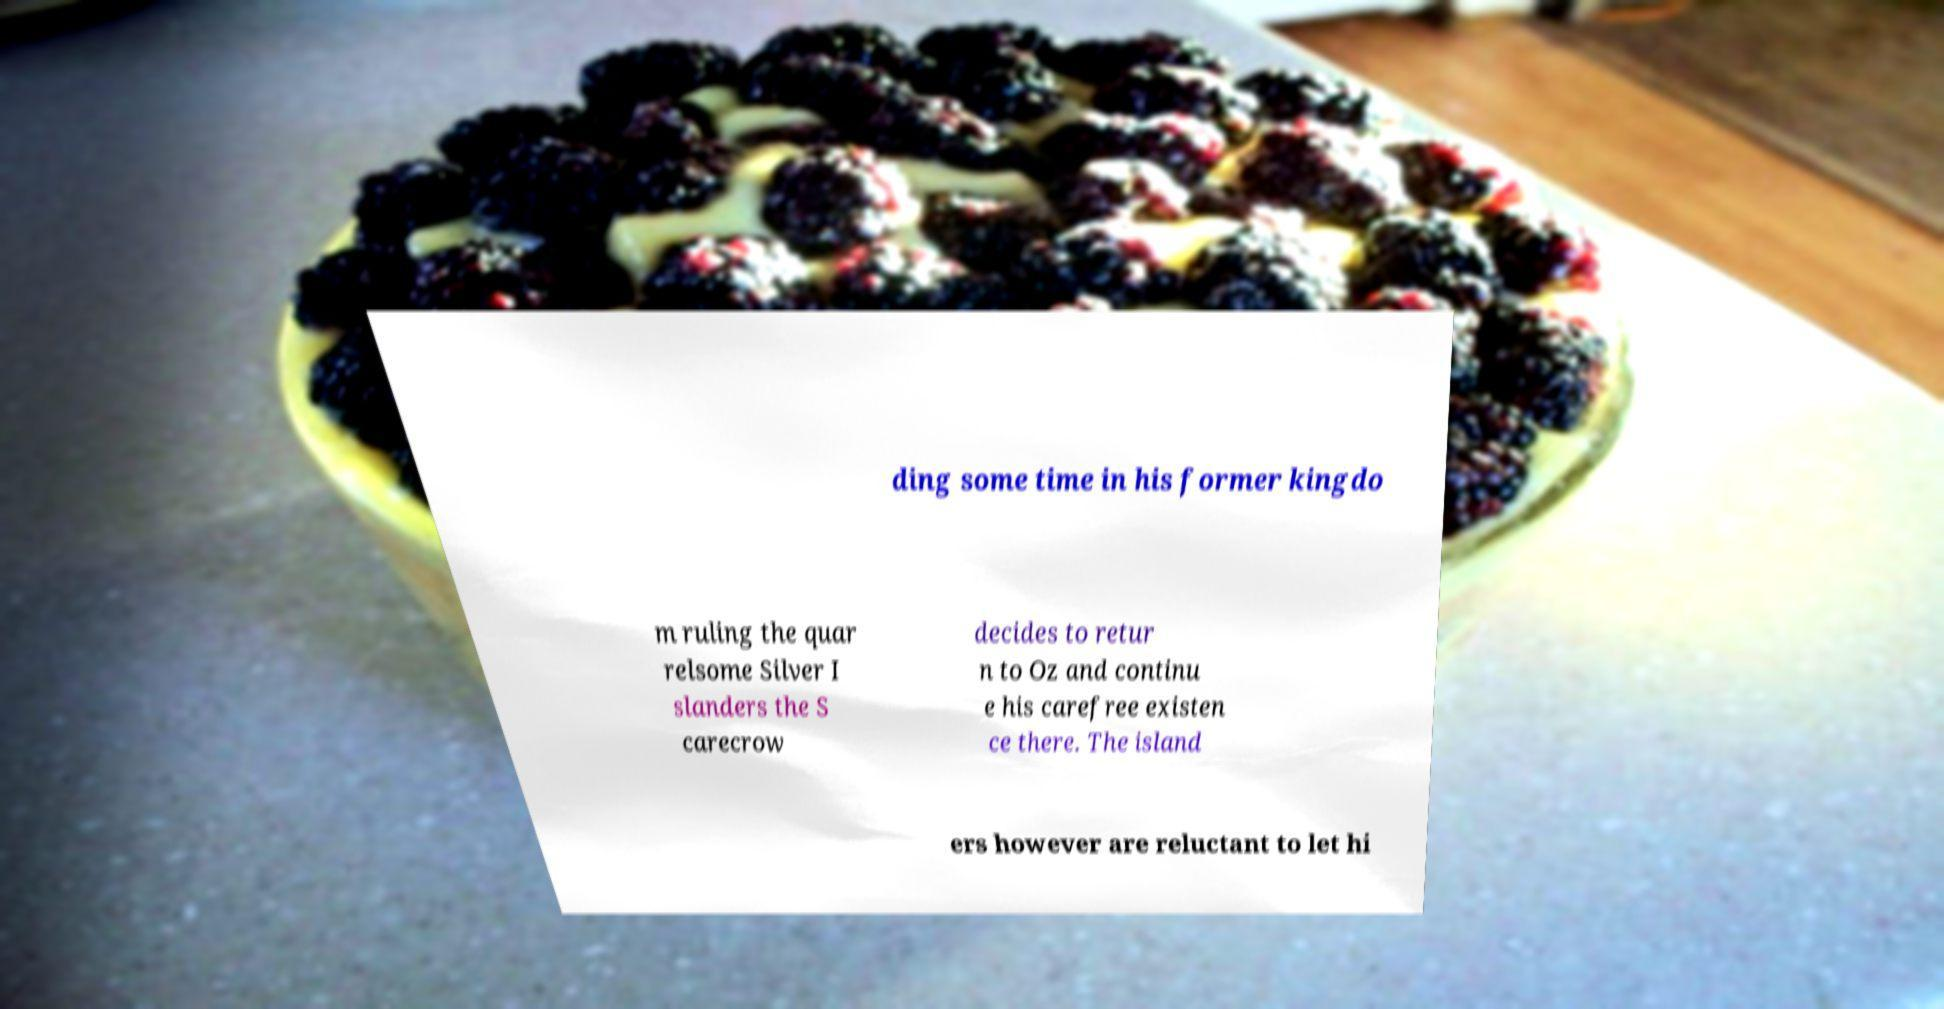Please identify and transcribe the text found in this image. ding some time in his former kingdo m ruling the quar relsome Silver I slanders the S carecrow decides to retur n to Oz and continu e his carefree existen ce there. The island ers however are reluctant to let hi 